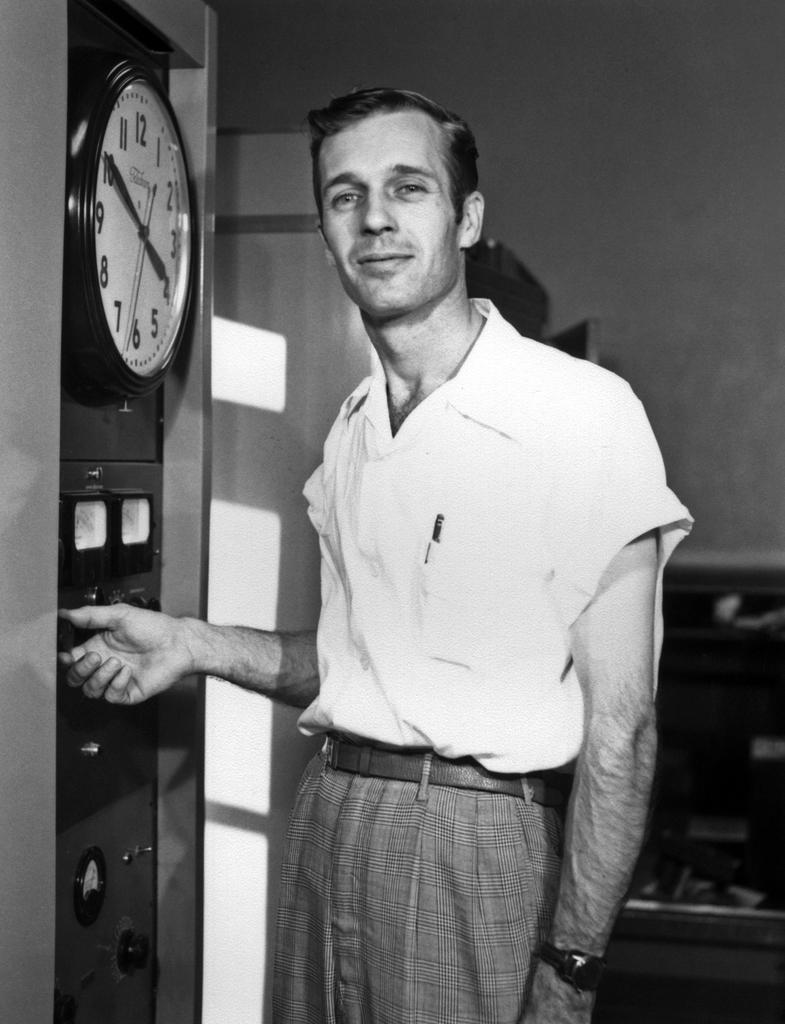<image>
Describe the image concisely. A man is standing next to a clock that shows the time "4:50." 